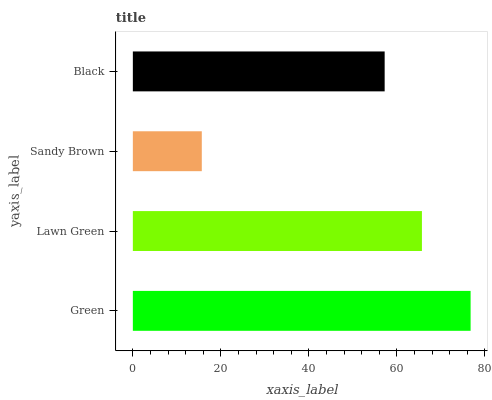Is Sandy Brown the minimum?
Answer yes or no. Yes. Is Green the maximum?
Answer yes or no. Yes. Is Lawn Green the minimum?
Answer yes or no. No. Is Lawn Green the maximum?
Answer yes or no. No. Is Green greater than Lawn Green?
Answer yes or no. Yes. Is Lawn Green less than Green?
Answer yes or no. Yes. Is Lawn Green greater than Green?
Answer yes or no. No. Is Green less than Lawn Green?
Answer yes or no. No. Is Lawn Green the high median?
Answer yes or no. Yes. Is Black the low median?
Answer yes or no. Yes. Is Green the high median?
Answer yes or no. No. Is Sandy Brown the low median?
Answer yes or no. No. 